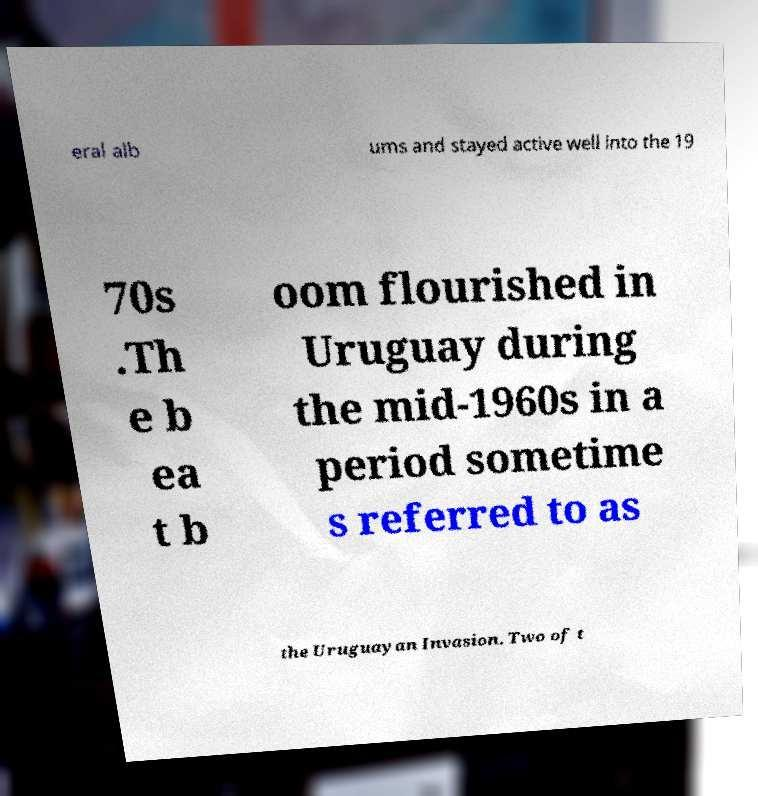I need the written content from this picture converted into text. Can you do that? eral alb ums and stayed active well into the 19 70s .Th e b ea t b oom flourished in Uruguay during the mid-1960s in a period sometime s referred to as the Uruguayan Invasion. Two of t 